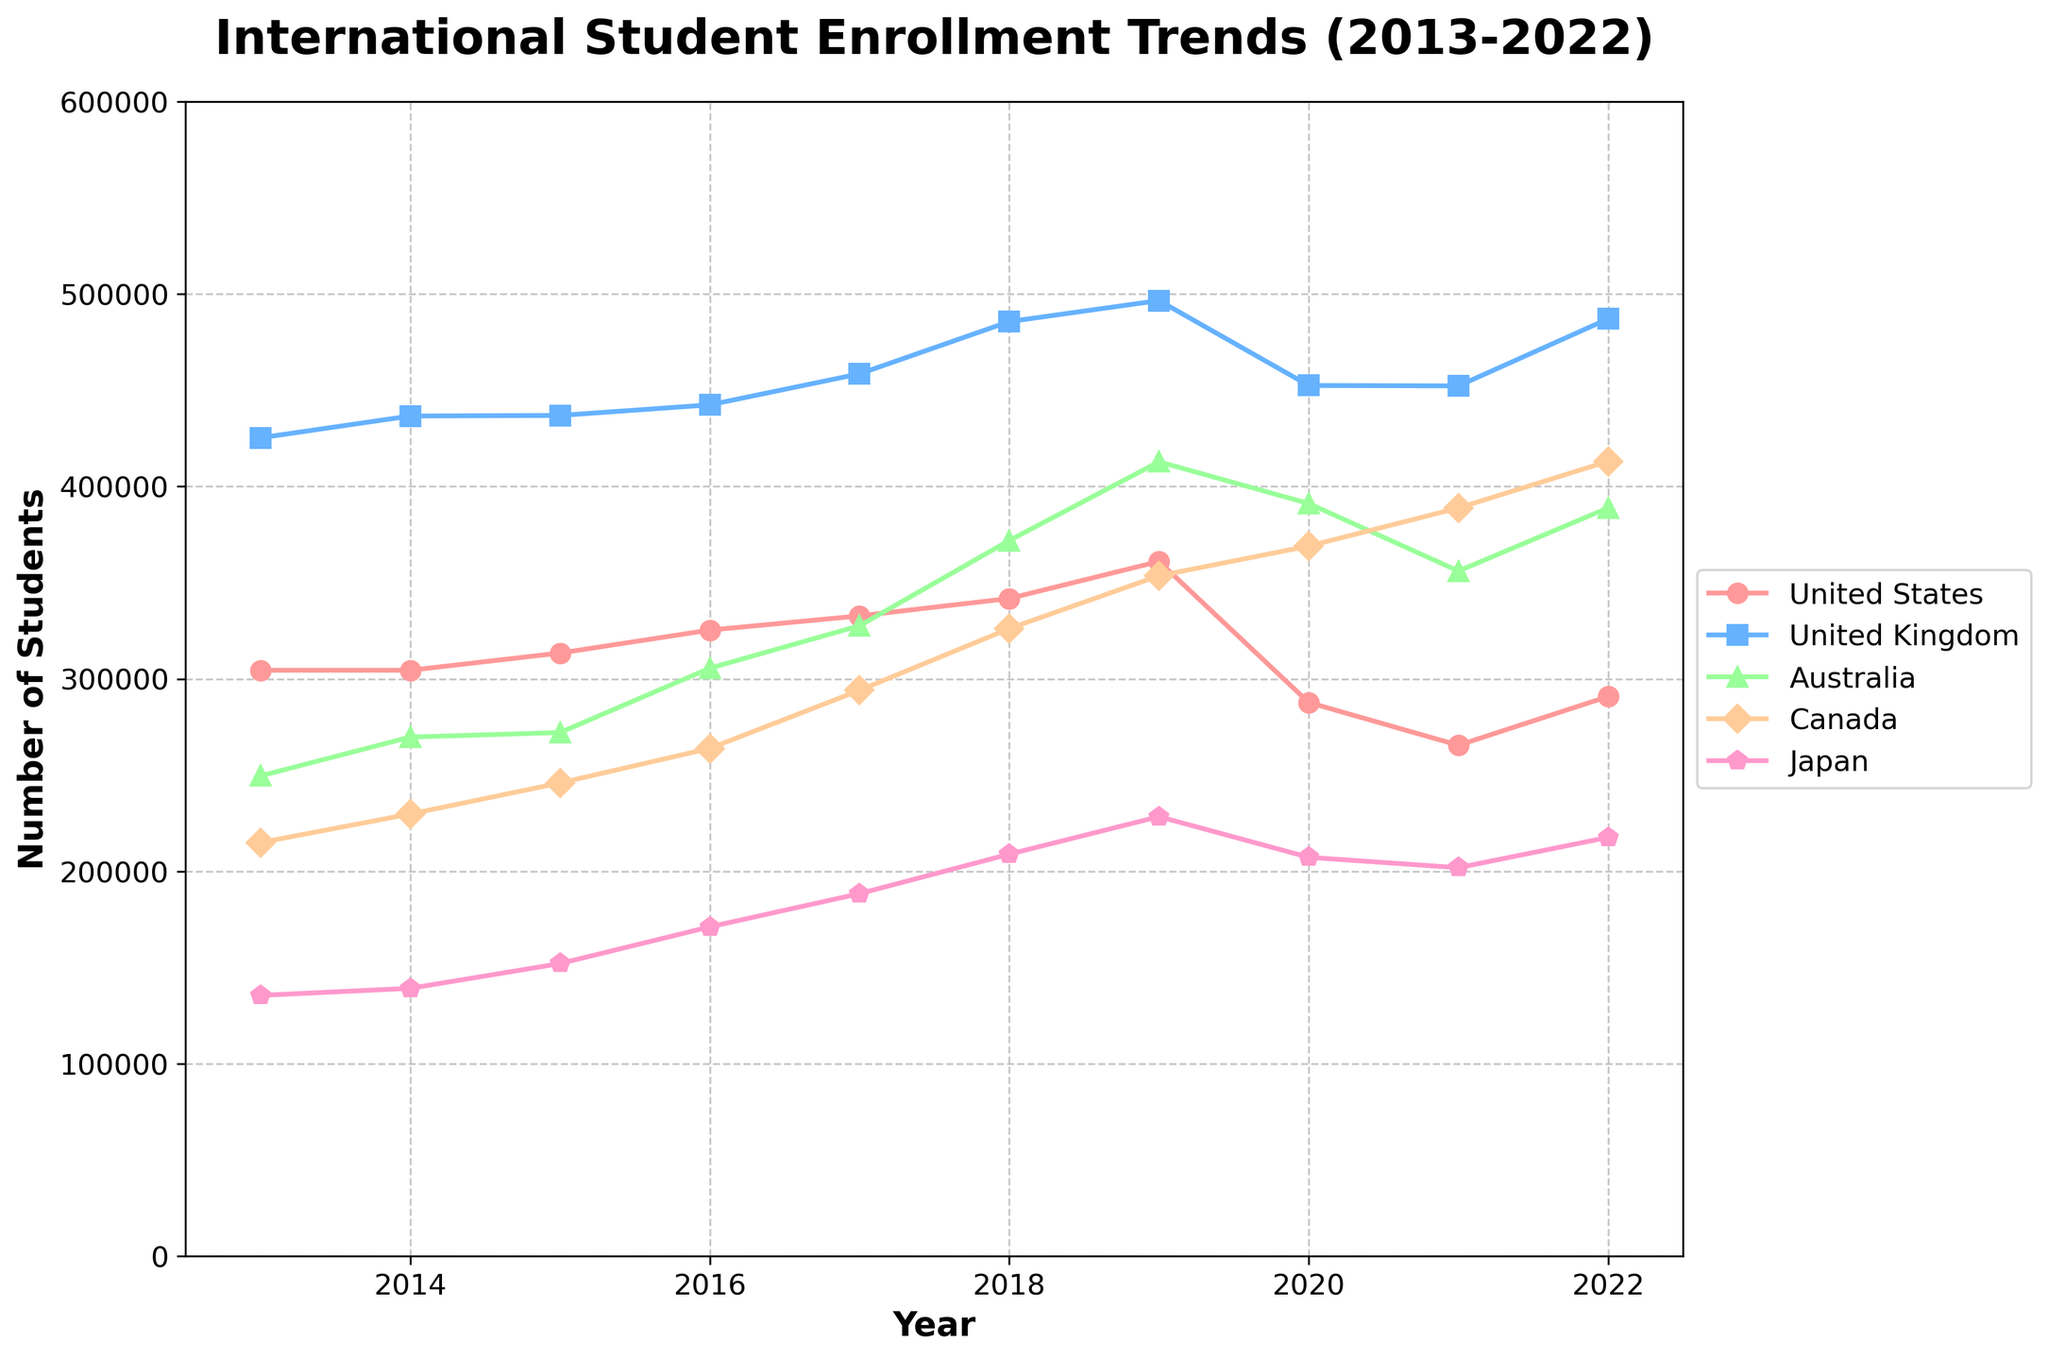What trend can be observed for international student enrollment in the United Kingdom from 2013 to 2022? The enrollment in the UK shows an overall increasing trend from 2013 (425,265) to 2022 (487,075), despite a small drop in 2020 and 2021.
Answer: Increasing Which country had the highest number of international students in 2019? The highest number is over 496,570 in the United Kingdom in 2019 based on the plotted values.
Answer: United Kingdom How did the number of students in the United States change from 2019 to 2022? The number of students in the US decreased from 360,996 in 2019 to 265,496 in 2021, then increased to 290,836 in 2022.
Answer: Decreased, then increased Between Japan and Germany, which country saw a higher increase in enrollment between 2013 and 2022? Japan increased from 135,519 to 217,626 (82,107 increase), while Germany increased from 206,986 to 286,341 (79,355 increase).
Answer: Japan What was the enrollment peak year for Australia's international students in this data set? The peak enrollment year for Australia was 2019, with 412,790 students.
Answer: 2019 By how much did the enrollment in Canada increase from 2013 to 2022? Enrollment in Canada increased from 214,955 in 2013 to 413,045 in 2022. The increase is 413,045 - 214,955 = 198,090.
Answer: 198,090 Which country experienced the most significant drop in international student enrollment during the COVID-19 pandemic (2020)? The United States saw the most significant drop from 360,996 in 2019 to 287,732 in 2020 (a reduction of 73,264).
Answer: United States Compare the trends of the United States and the United Kingdom from 2013 to 2022. The U.S. shows fluctuations with a significant drop around 2020 and partial recovery by 2022. The UK shows a generally consistent upward trend, with a slight dip around 2020 but recovered to reach a new peak in 2022.
Answer: Fluctuations/partial recovery vs consistent upward How does the number of international students in France in 2022 compare to 2013? Enrollment in France increased from 289,274 in 2013 to 365,386 in 2022.
Answer: Increased What noticeable pattern can be observed in the international student trends for Japan from 2014 to 2016? Japan shows a steady increase each year, from 139,185 in 2014 to 171,122 in 2016.
Answer: Steady increase 